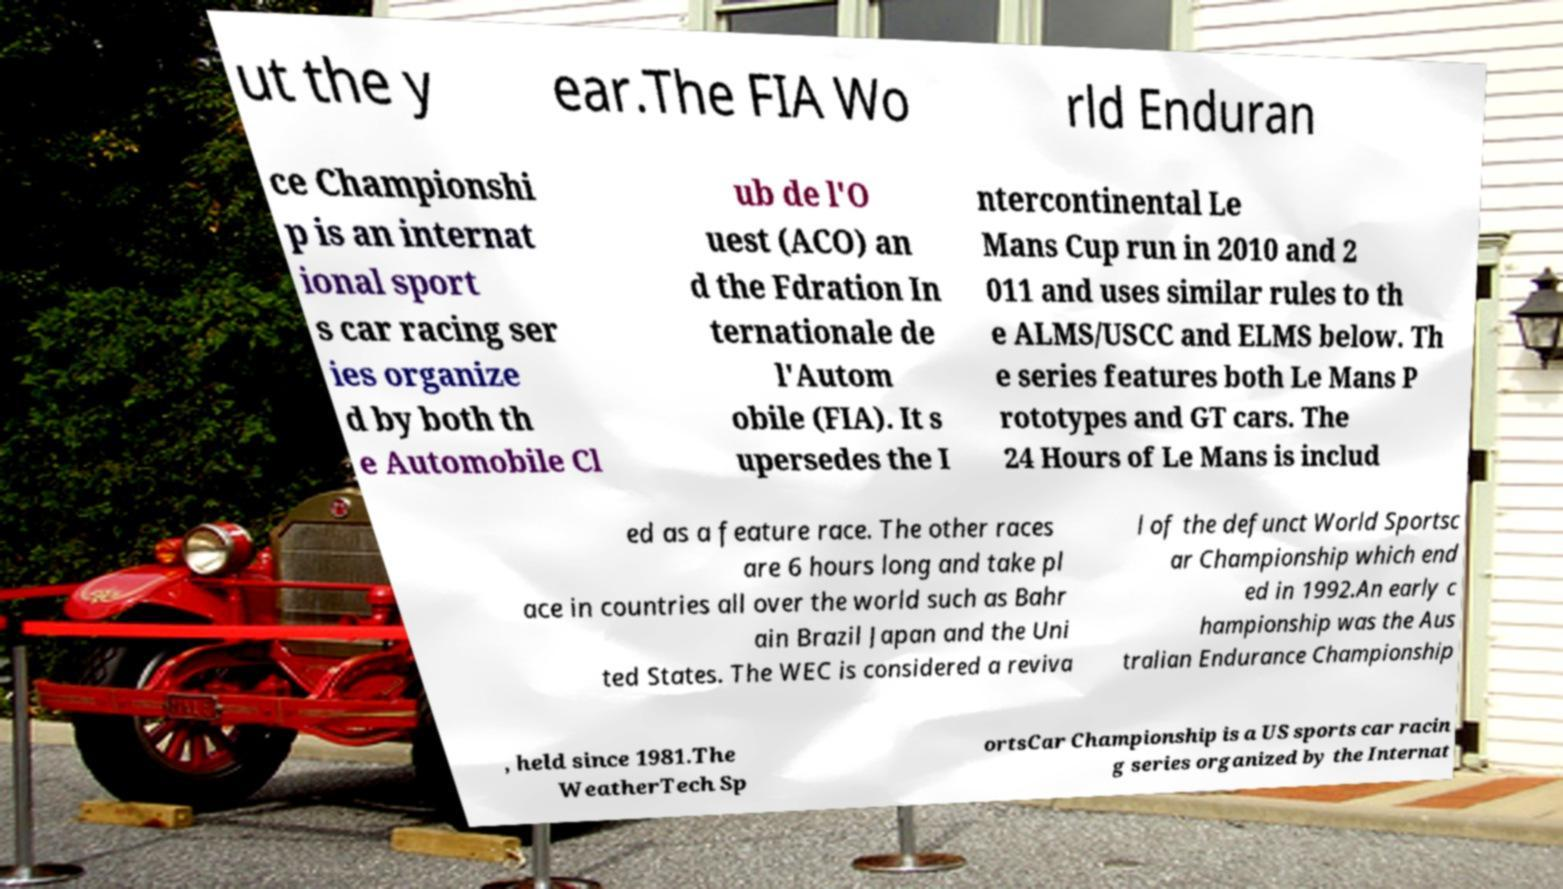What messages or text are displayed in this image? I need them in a readable, typed format. ut the y ear.The FIA Wo rld Enduran ce Championshi p is an internat ional sport s car racing ser ies organize d by both th e Automobile Cl ub de l'O uest (ACO) an d the Fdration In ternationale de l'Autom obile (FIA). It s upersedes the I ntercontinental Le Mans Cup run in 2010 and 2 011 and uses similar rules to th e ALMS/USCC and ELMS below. Th e series features both Le Mans P rototypes and GT cars. The 24 Hours of Le Mans is includ ed as a feature race. The other races are 6 hours long and take pl ace in countries all over the world such as Bahr ain Brazil Japan and the Uni ted States. The WEC is considered a reviva l of the defunct World Sportsc ar Championship which end ed in 1992.An early c hampionship was the Aus tralian Endurance Championship , held since 1981.The WeatherTech Sp ortsCar Championship is a US sports car racin g series organized by the Internat 